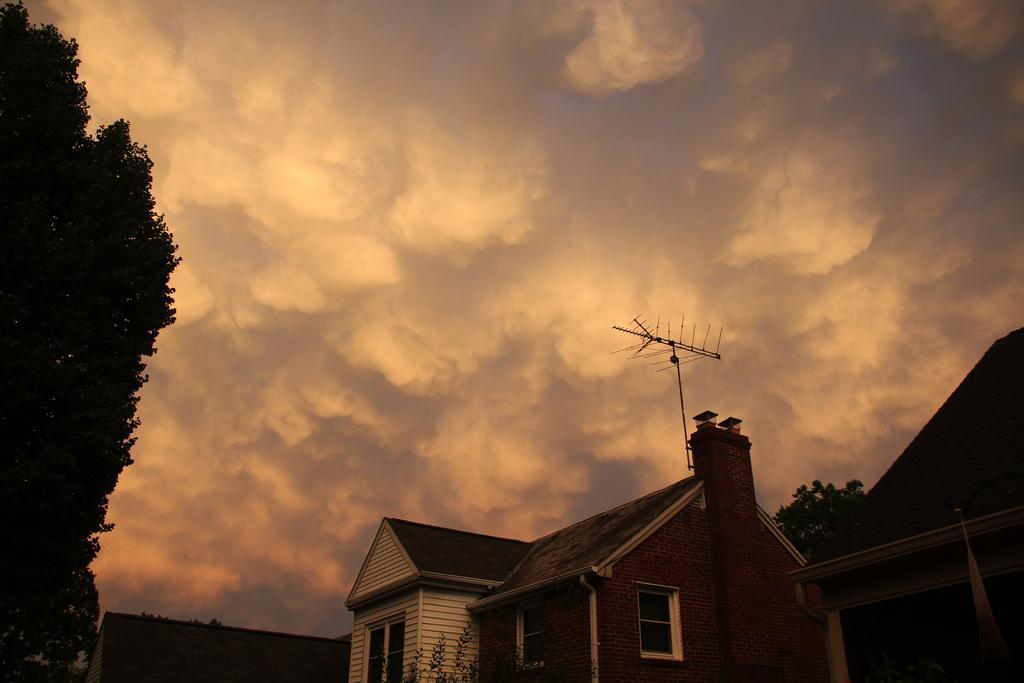Could you give a brief overview of what you see in this image? In this image we can see sky with clouds, trees, buildings and antennas. 